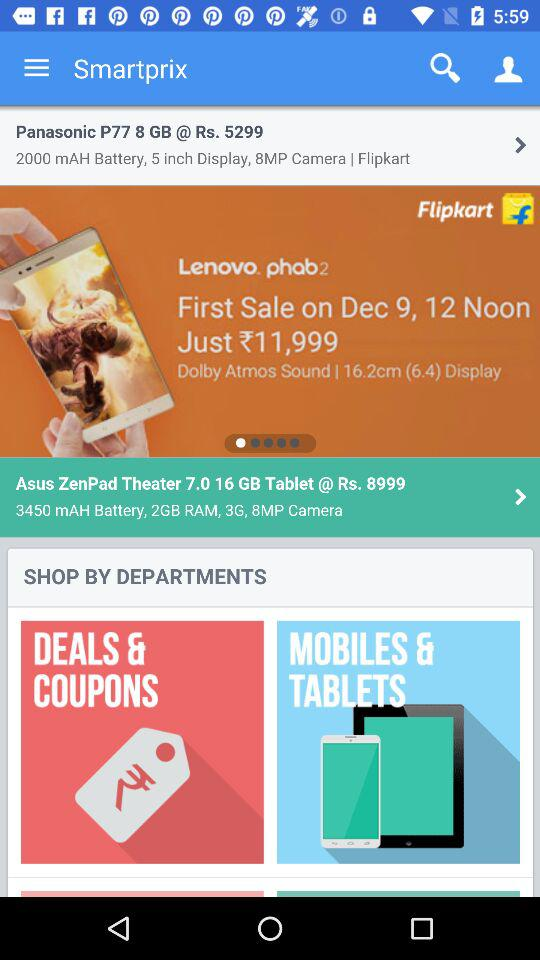What is the price of the "Asus Zenpad Theater"? The price of the "Asus Zenpad Theater" is Rs. 8,999. 